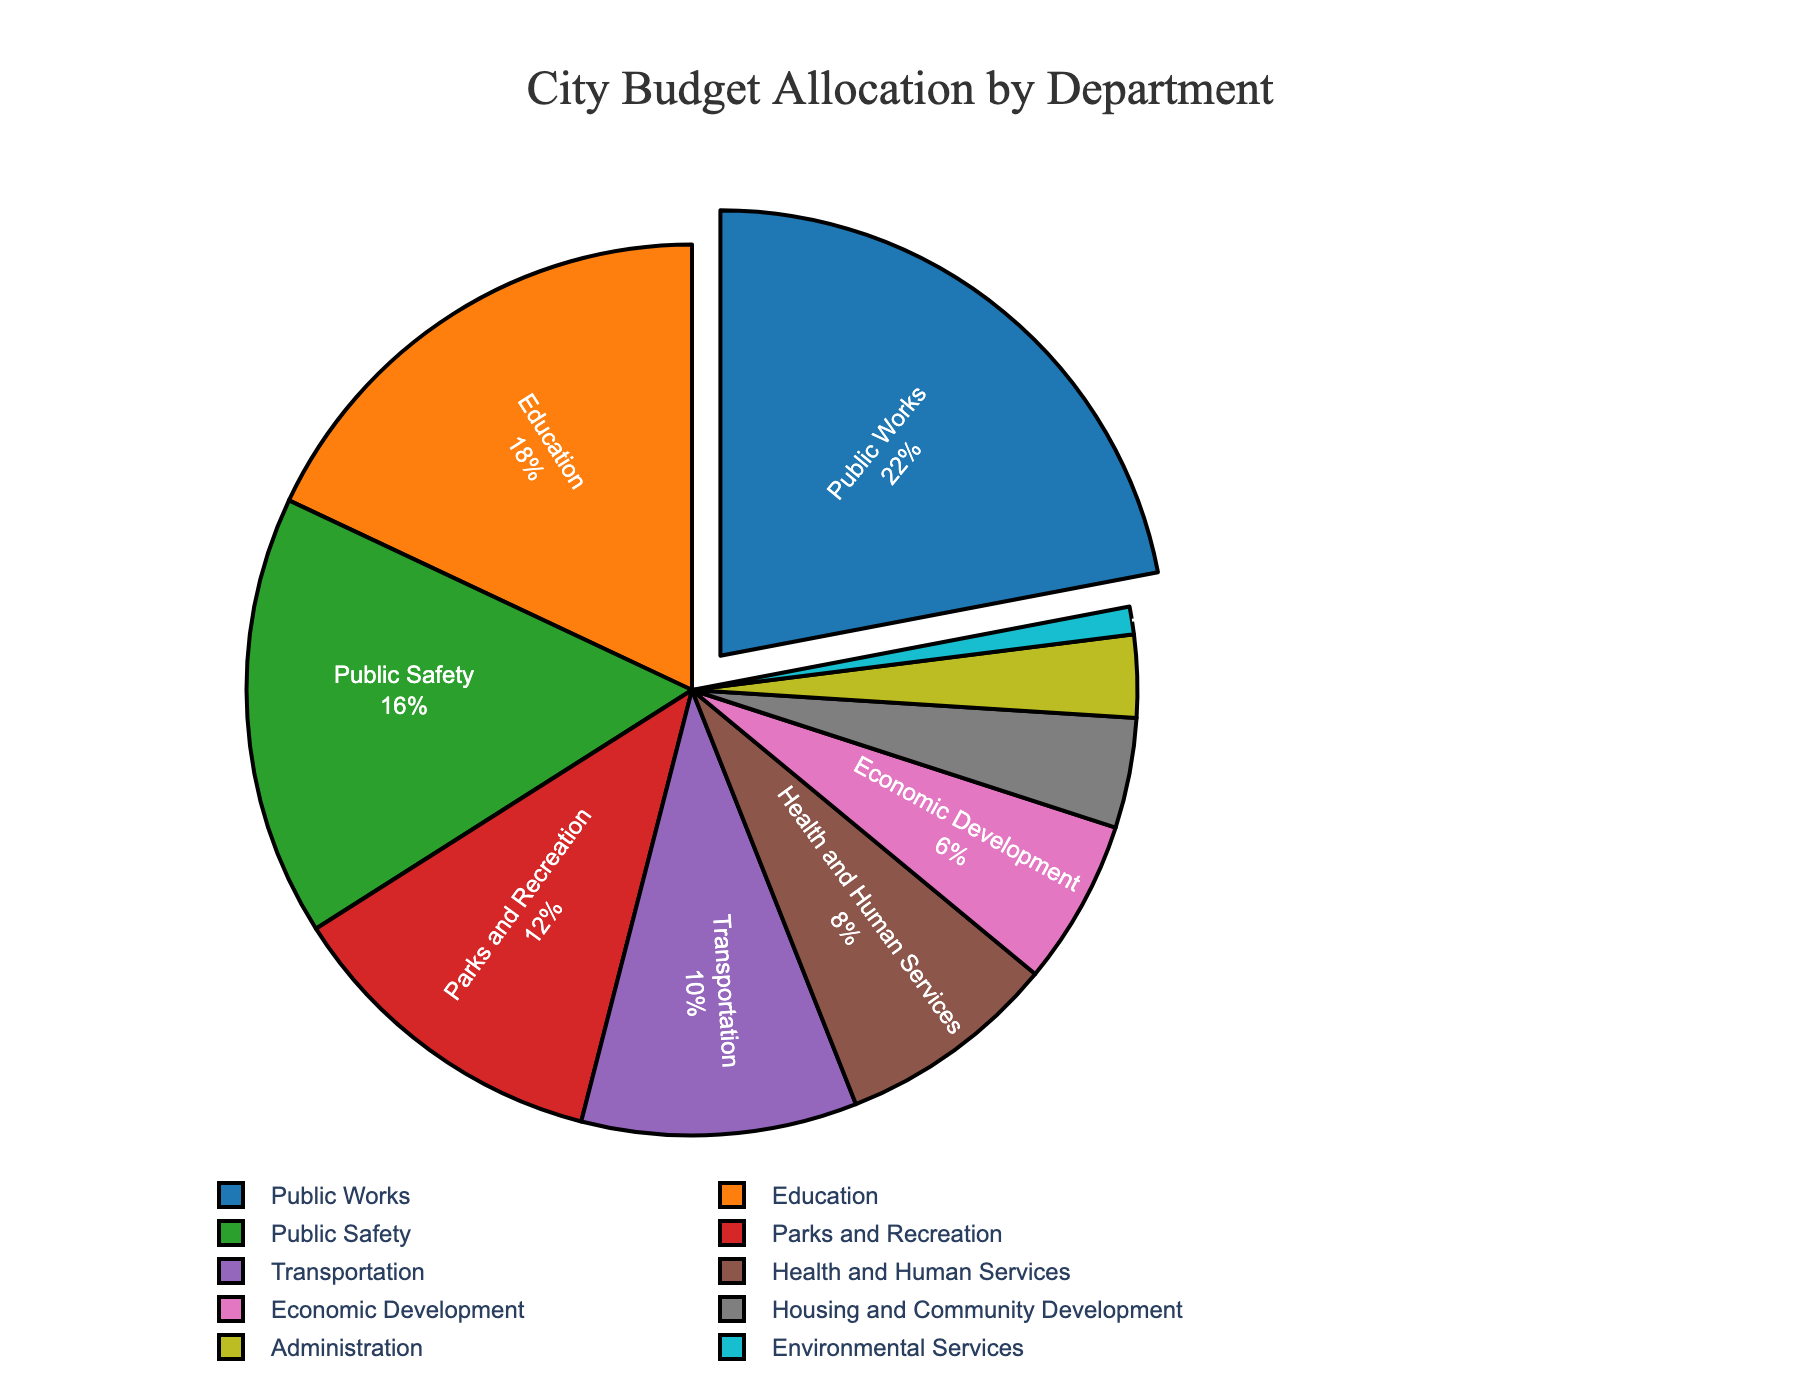Which department receives the highest percentage of the budget? The chart shows that Public Works receives the highest budget allocation as its slice is pulled out and has the largest size at 22%.
Answer: Public Works What is the combined budget allocation for Education and Public Safety? According to the chart, Education gets 18% and Public Safety receives 16%. Adding these together: 18% + 16% = 34%.
Answer: 34% Which department receives a smaller budget allocation, Parks and Recreation or Health and Human Services? Parks and Recreation gets 12%, and Health and Human Services receives 8%. Therefore, Health and Human Services gets a smaller allocation.
Answer: Health and Human Services How much more does the Transportation department receive than Housing and Community Development? The chart indicates Transportation gets 10%, while Housing and Community Development receives 4%. The difference is calculated as 10% - 4% = 6%.
Answer: 6% Rank the departments with more than 10% budget allocation from highest to lowest. According to the chart, the departments with more than 10% are Public Works (22%), Education (18%), Public Safety (16%), and Parks and Recreation (12%). The rank from highest to lowest is Public Works, Education, Public Safety, Parks and Recreation.
Answer: Public Works, Education, Public Safety, Parks and Recreation Which department receives the least budget allocation? The chart shows that Environmental Services has the smallest slice and receives only 1% of the budget.
Answer: Environmental Services What is the total budget allocation for departments receiving less than 10% individually? The departments with less than 10% each are Health and Human Services (8%), Economic Development (6%), Housing and Community Development (4%), Administration (3%), and Environmental Services (1%). Adding these together: 8% + 6% + 4% + 3% + 1% = 22%.
Answer: 22% Are there more departments receiving between 10-20% or less than 10% of the budget? The chart shows four departments receiving 10-20% (Public Works, Education, Public Safety, Parks and Recreation) and five departments receiving less than 10% (Health and Human Services, Economic Development, Housing and Community Development, Administration, Environmental Services).
Answer: Less than 10% Which two departments together make up exactly half of the budget? According to the chart, Public Works and Education receive 22% and 18%, respectively. Adding these: 22% + 18% = 40%, which is not half. The correct pair is Public Works (22%) and Public Safety (16%) together summing up to 38%, which is not correct. None of the two departments combined make 50%.
Answer: None 